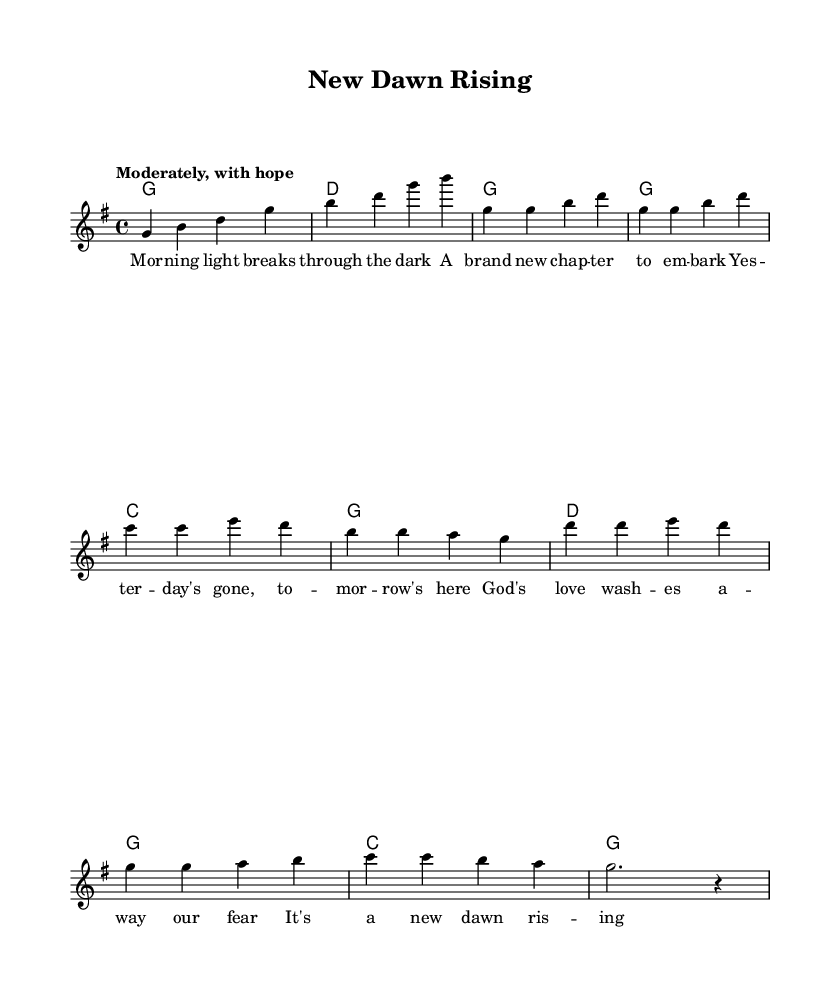What is the key signature of this music? The key signature is G major, which has one sharp (F#). This is determined by looking at the key indicated within the global musical context at the beginning of the sheet music.
Answer: G major What is the time signature of this music? The time signature is 4/4, which means there are four beats in each measure, and a quarter note receives one beat. This can be found prominently displayed alongside the key signature in the global section of the score.
Answer: 4/4 What is the tempo marking of this piece? The tempo marking is "Moderately, with hope." This expression is noted at the beginning of the score, indicating the desired speed and emotional feel of the music.
Answer: Moderately, with hope How many measures are in the verse section? There are eight measures in the verse section, which includes the sequence of musical phrases indicated under the melody and the corresponding lyrics. Count the measures by looking at the notation before transitioning to the chorus.
Answer: Eight What is the main theme of the chorus lyrics? The main theme of the chorus lyrics is hope and renewal, stressing that every moment represents a fresh start and God's grace. This can be deduced from analyzing the phrases within the chorus lyrics focusing on new beginnings.
Answer: Hope and renewal What chord follows the melody in the second measure? The chord that follows the melody in the second measure is G major, as indicated in the chord mode section aligned with the melody's progression. This structural relationship is evident in the score layout.
Answer: G major Which part of the music features a change in harmony? The harmony changes at the chorus section, where the chord structure shifts to create contrast and emphasize the lyrical message. This is reflected in the arrangement of harmonies listed in the score, particularly between the verse and chorus.
Answer: Chorus section 